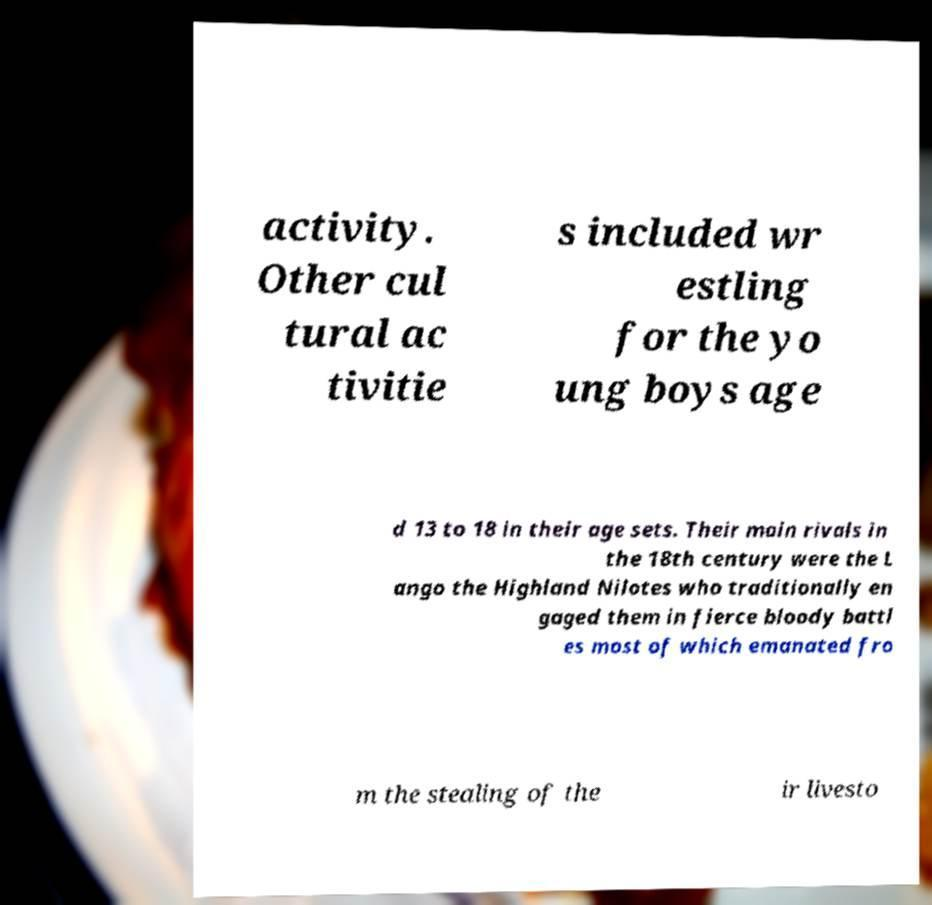I need the written content from this picture converted into text. Can you do that? activity. Other cul tural ac tivitie s included wr estling for the yo ung boys age d 13 to 18 in their age sets. Their main rivals in the 18th century were the L ango the Highland Nilotes who traditionally en gaged them in fierce bloody battl es most of which emanated fro m the stealing of the ir livesto 